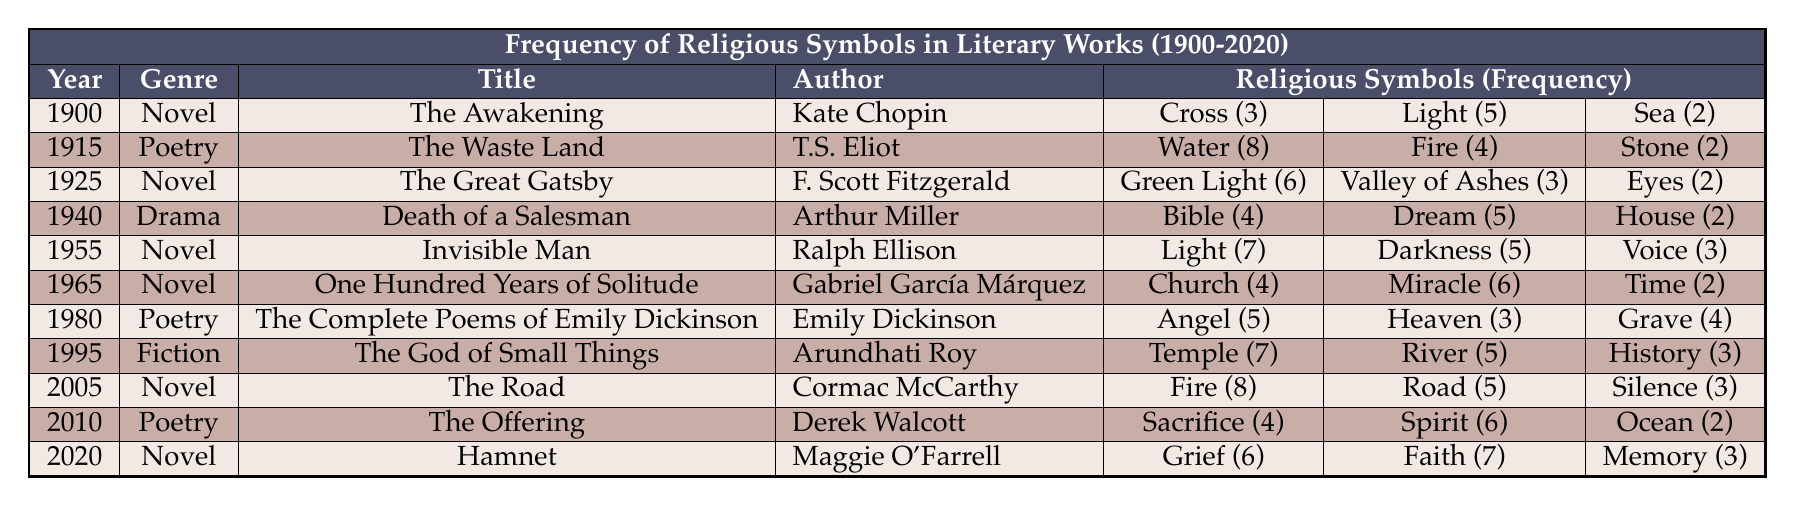What is the title of the novel published in 1955? The table indicates that the title of the novel published in 1955 is "Invisible Man."
Answer: Invisible Man Which genre has the highest frequency of religious symbols and what is that frequency? Looking through the table, "The Road" from the novel genre in 2005 has the highest frequency of religious symbols with a count of 8 for fire.
Answer: Novel, 8 How many religious symbols are mentioned in "The Waste Land"? By examining the table, the religious symbols in "The Waste Land" total to 14 (water 8 + fire 4 + stone 2 = 14).
Answer: 14 Is there a work from the drama genre that references the Bible? According to the table, "Death of a Salesman" (1940) does reference the Bible, with a frequency of 4.
Answer: Yes What is the average frequency of religious symbols in the poetry genre? The total frequency for poetry (The Waste Land: 14, The Complete Poems: 12, The Offering: 12) is 38. Dividing by 3 gives an average of approximately 12.67.
Answer: 12.67 Which author has the most varied representation of religious symbols and what is the sum of those symbols? Upon checking the table, Arundhati Roy (1995) mentions 3 different symbols (temple 7, river 5, history 3) totaling 15, while others have lesser counts, indicating her work has the most varied representation.
Answer: Arundhati Roy, 15 In which year did the representation of religious symbols in novels increase sharply compared to previous years? Analyzing the table, the year 2005 shows a notable increase for "The Road" with 8 occurrences for fire, a significant rise from prior years.
Answer: 2005 Are there any works from the novel genre that reference 'light' as a symbol? The table shows both "The Awakening" (1900) with 5 and "Invisible Man" (1955) with 7 as references to light, confirming the occurrence.
Answer: Yes What is the total frequency of 'sea', 'river', and 'ocean' symbols across the different works listed? By summarizing the counts from the table: sea (2), river (5), and ocean (2), it results in a total of 9.
Answer: 9 How many years passed between the publications of "The Great Gatsby" and "Hamnet"? The difference between the years 1925 and 2020 is 95 years, indicating a significant time span between the two works.
Answer: 95 years 